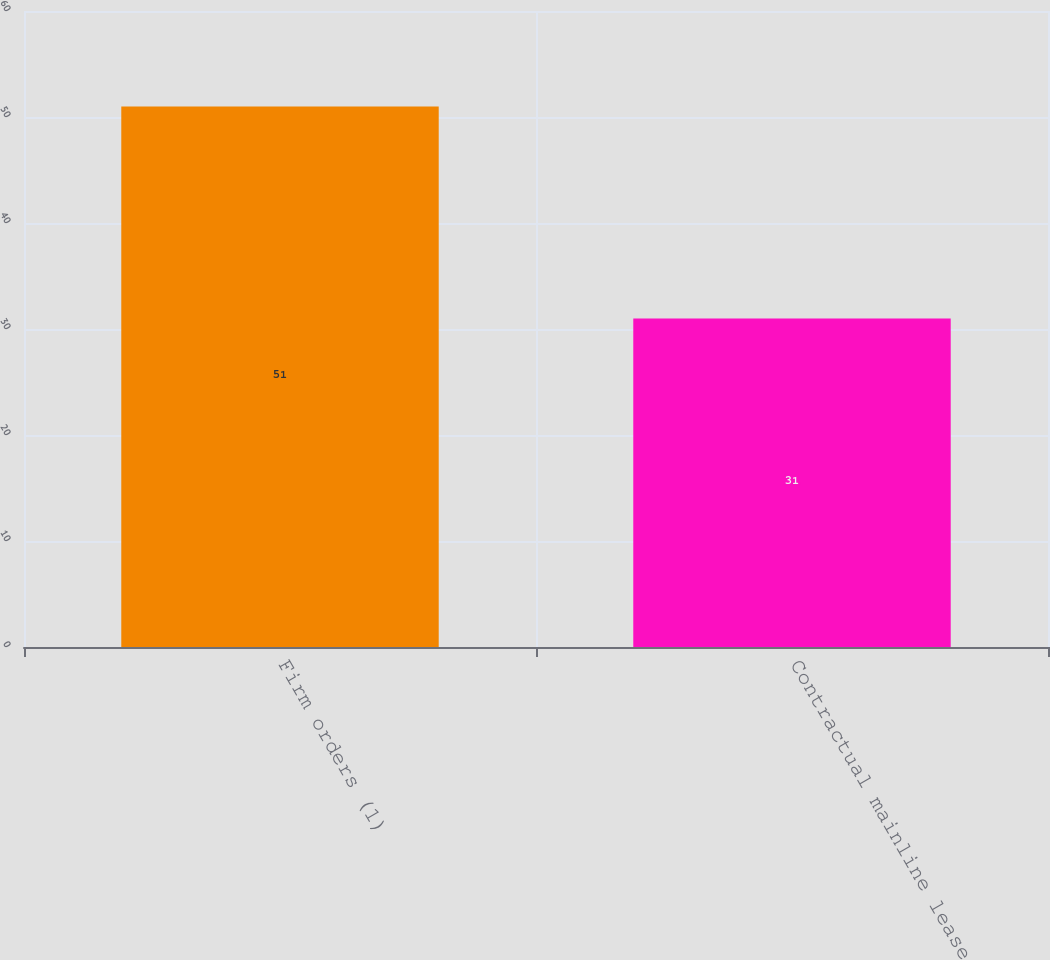Convert chart. <chart><loc_0><loc_0><loc_500><loc_500><bar_chart><fcel>Firm orders (1)<fcel>Contractual mainline lease<nl><fcel>51<fcel>31<nl></chart> 